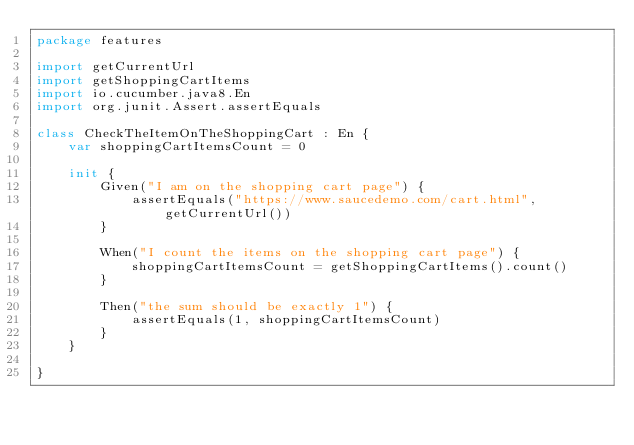Convert code to text. <code><loc_0><loc_0><loc_500><loc_500><_Kotlin_>package features

import getCurrentUrl
import getShoppingCartItems
import io.cucumber.java8.En
import org.junit.Assert.assertEquals

class CheckTheItemOnTheShoppingCart : En {
    var shoppingCartItemsCount = 0

    init {
        Given("I am on the shopping cart page") {
            assertEquals("https://www.saucedemo.com/cart.html", getCurrentUrl())
        }

        When("I count the items on the shopping cart page") {
            shoppingCartItemsCount = getShoppingCartItems().count()
        }

        Then("the sum should be exactly 1") {
            assertEquals(1, shoppingCartItemsCount)
        }
    }

}</code> 